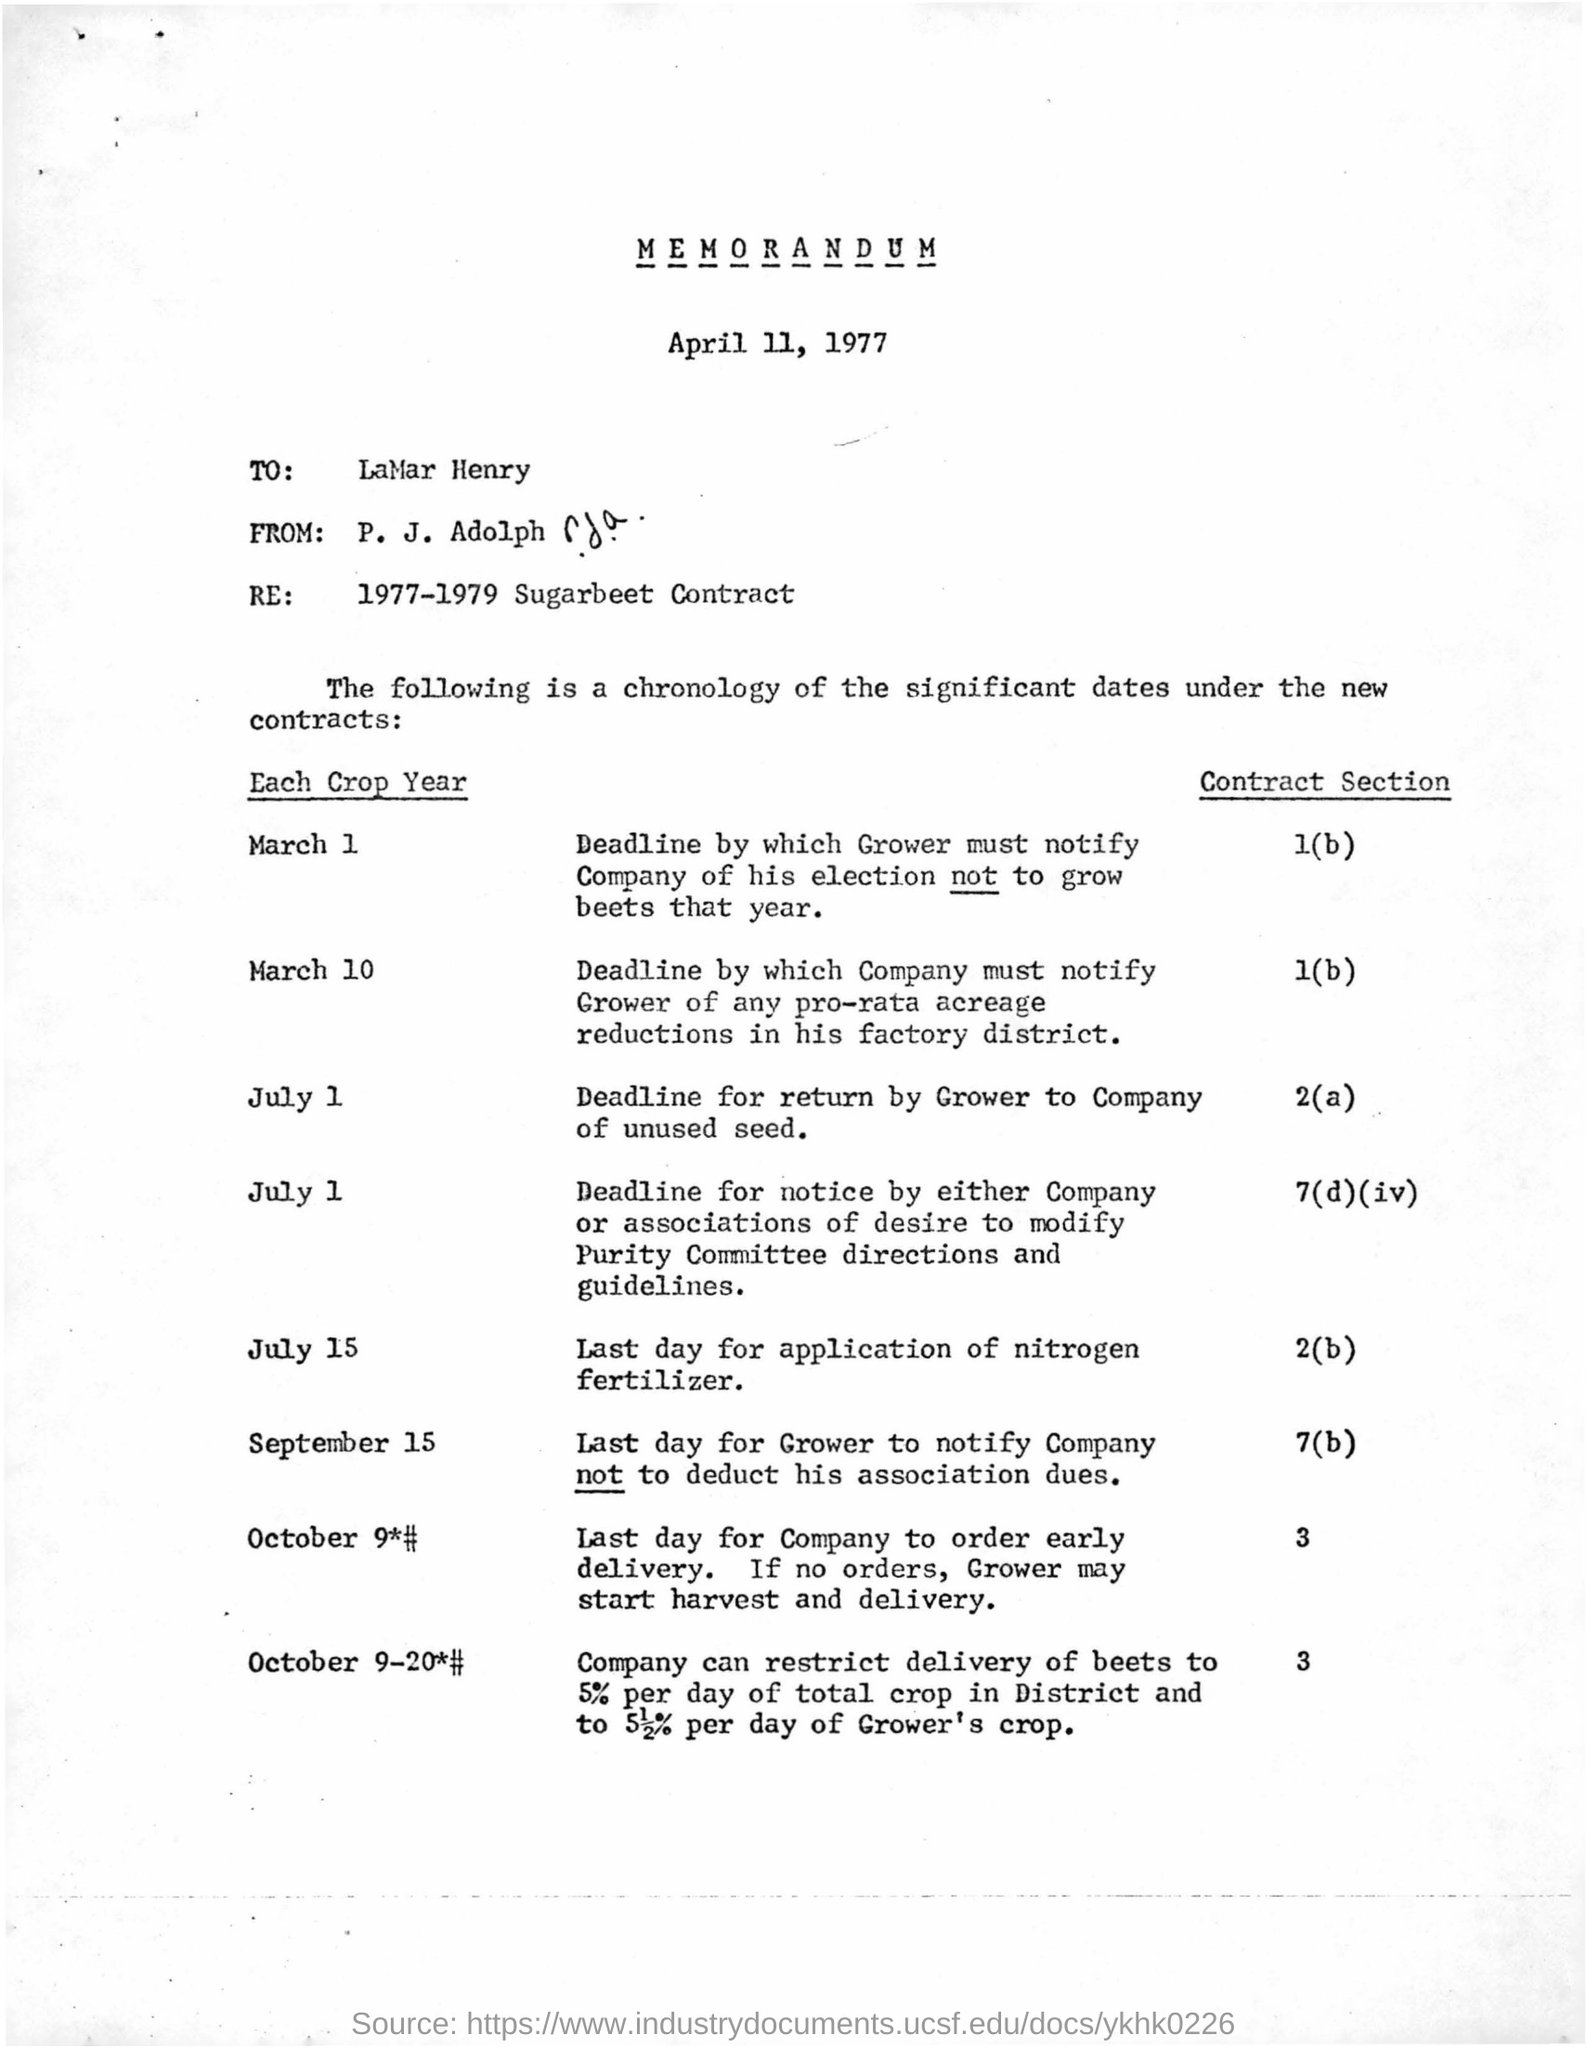What is the date mentioned in the letter?
Give a very brief answer. April 11, 1977. Who wrote this letter to lamar henry?
Offer a terse response. P. J. Adolph. 